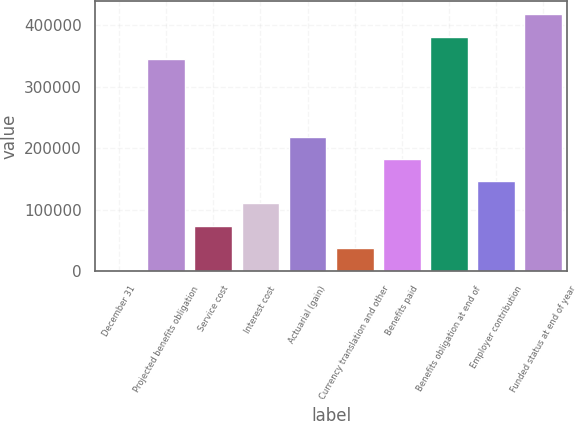<chart> <loc_0><loc_0><loc_500><loc_500><bar_chart><fcel>December 31<fcel>Projected benefits obligation<fcel>Service cost<fcel>Interest cost<fcel>Actuarial (gain)<fcel>Currency translation and other<fcel>Benefits paid<fcel>Benefits obligation at end of<fcel>Employer contribution<fcel>Funded status at end of year<nl><fcel>2007<fcel>345116<fcel>74188.8<fcel>110280<fcel>218552<fcel>38097.9<fcel>182462<fcel>381207<fcel>146371<fcel>417298<nl></chart> 